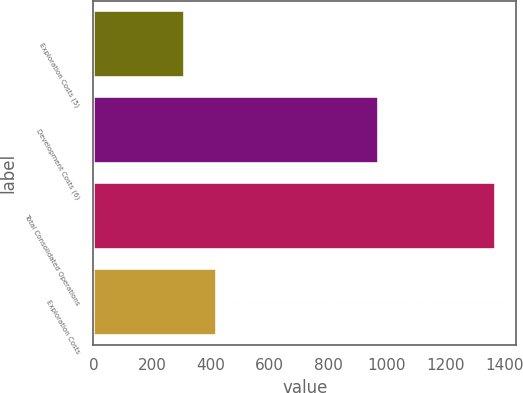<chart> <loc_0><loc_0><loc_500><loc_500><bar_chart><fcel>Exploration Costs (5)<fcel>Development Costs (6)<fcel>Total Consolidated Operations<fcel>Exploration Costs<nl><fcel>313<fcel>973<fcel>1373<fcel>420<nl></chart> 